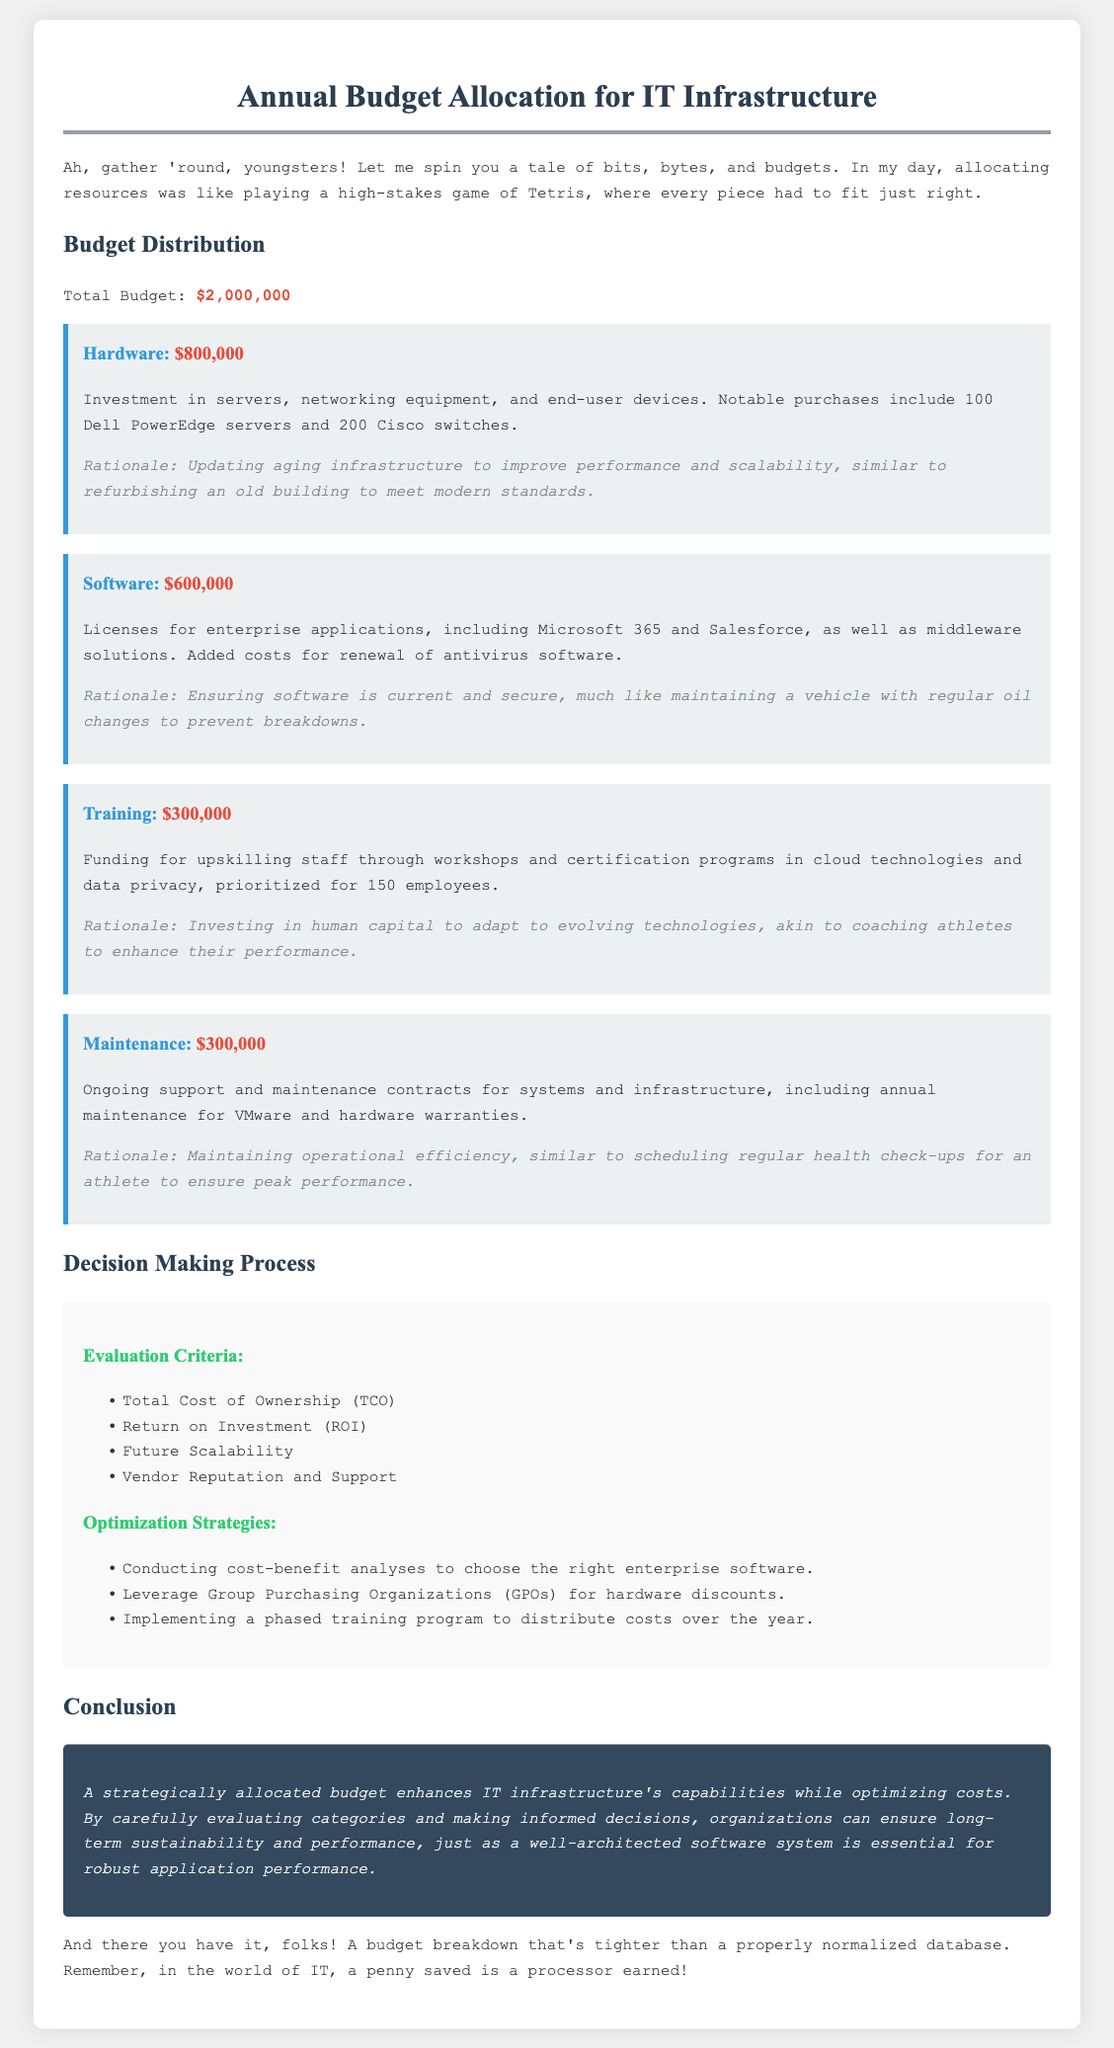What is the total budget? The total budget is explicitly mentioned at the beginning of the document.
Answer: $2,000,000 How much is allocated for hardware? The hardware budget section clearly states the amount allocated for it.
Answer: $800,000 What category received the least funding? By comparing the amounts in each category, the one with the smallest allocation can be identified.
Answer: Training What is one of the evaluation criteria mentioned for decision making? The document lists specific evaluation criteria, and any of them can be an answer.
Answer: Return on Investment What is the total amount allocated for maintenance? The maintenance budget section specifically lists the allocated amount for maintenance.
Answer: $300,000 Which hardware devices were notably purchased? The hardware section includes specific mentions of the purchased devices.
Answer: Dell PowerEdge servers and Cisco switches What optimization strategy involves group purchasing? The document lists specific strategies that contribute to cost optimization, including this one.
Answer: Leverage Group Purchasing Organizations What is the rationale for software investment? The reasoning section for software provides insights into the necessity of this investment.
Answer: Maintaining a vehicle with regular oil changes In which section does the conclusion appear? The document organizes content into clear sections, including one for conclusions.
Answer: Conclusion 